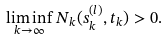<formula> <loc_0><loc_0><loc_500><loc_500>\liminf _ { k \rightarrow \infty } N _ { k } ( s _ { k } ^ { ( l ) } , t _ { k } ) > 0 .</formula> 